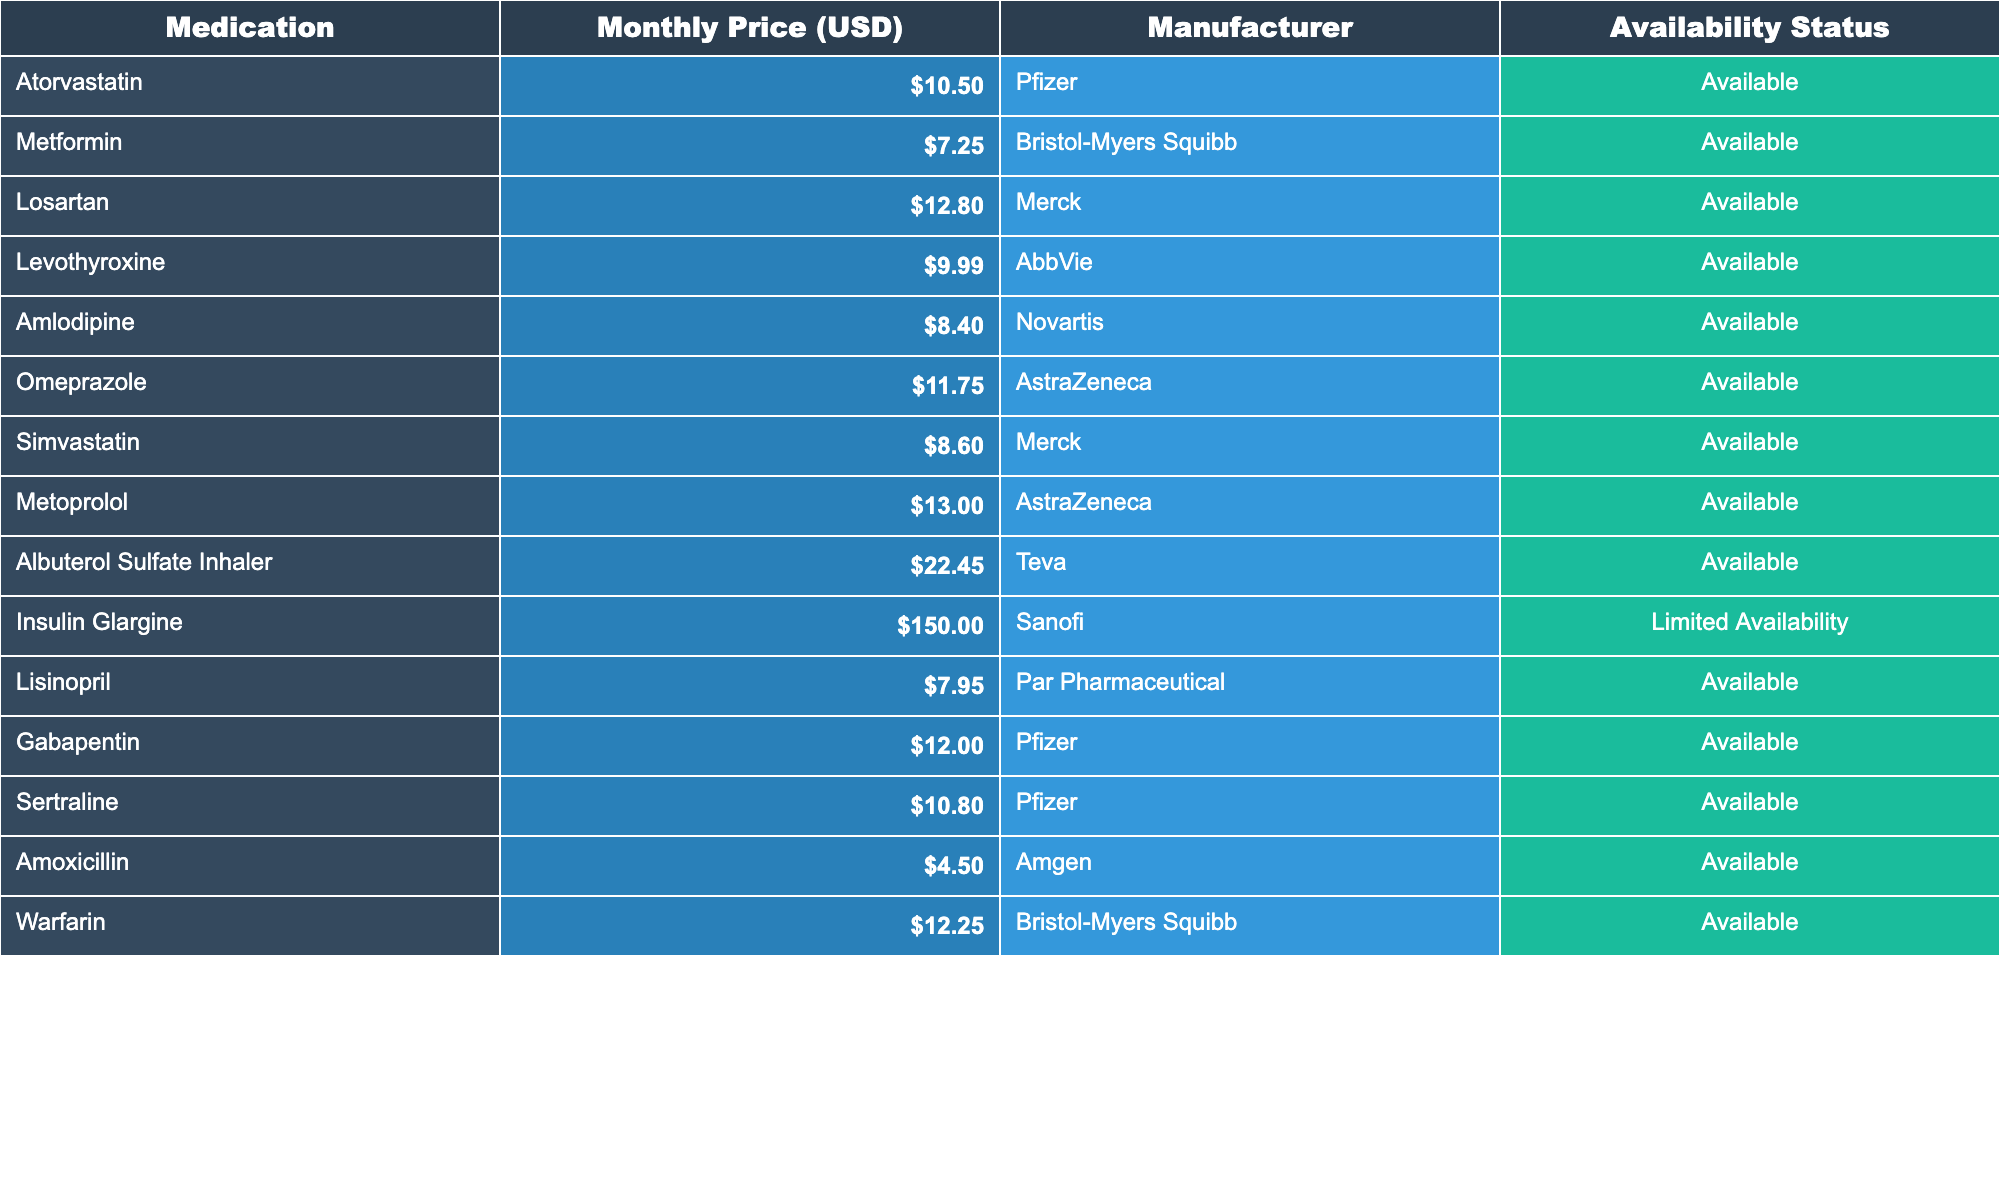What is the monthly price of Metformin? The table lists the medication Metformin and shows its Monthly Price (USD) as **$7.25**.
Answer: $7.25 Which medication has the highest monthly price? By looking at the Monthly Prices, the highest value is **$150.00** for Insulin Glargine.
Answer: $150.00 How much does Amoxicillin cost? Amoxicillin is listed in the table with a Monthly Price of **$4.50**.
Answer: $4.50 Is Losartan available? The Availability Status for Losartan is marked as **Available**, indicating it can be obtained.
Answer: Yes What is the average price of the medications listed? The Monthly Prices are summed: ($10.50 + $7.25 + $12.80 + $9.99 + $8.40 + $11.75 + $8.60 + $13.00 + $22.45 + $150.00 + $7.95 + $12.00 + $10.80 + $4.50 + $12.25) = $285.10. There are 15 medications, so the average is $285.10 / 15 = $19.01.
Answer: $19.01 How many medications have a price below $10? The medications priced below $10 are Atorvastatin, Metformin, Levothyroxine, Amlodipine, Simvastatin, Lisinopril, Gabapentin, and Amoxicillin. There are 8 medications in total.
Answer: 8 Which medication is manufactured by Pfizer? In the table, both Atorvastatin and Gabapentin are listed as being manufactured by Pfizer.
Answer: Atorvastatin and Gabapentin What percentage of the medications are available? There are 14 medications listed as available out of 15 total. The percentage is (14/15) * 100 = 93.33%.
Answer: 93.33% If we exclude the highest-priced medication, what is the new average price? First, remove Insulin Glargine from the price list. The sum of the remaining prices is ($10.50 + $7.25 + $12.80 + $9.99 + $8.40 + $11.75 + $8.60 + $13.00 + $22.45 + $7.95 + $12.00 + $10.80 + $4.50 + $12.25) = $266.40. Now divide by 14 (the count of remaining medications): $266.40 / 14 = $19.03.
Answer: $19.03 Are there any drugs with limited availability? Yes, the table indicates that Insulin Glargine has a status of **Limited Availability**.
Answer: Yes 